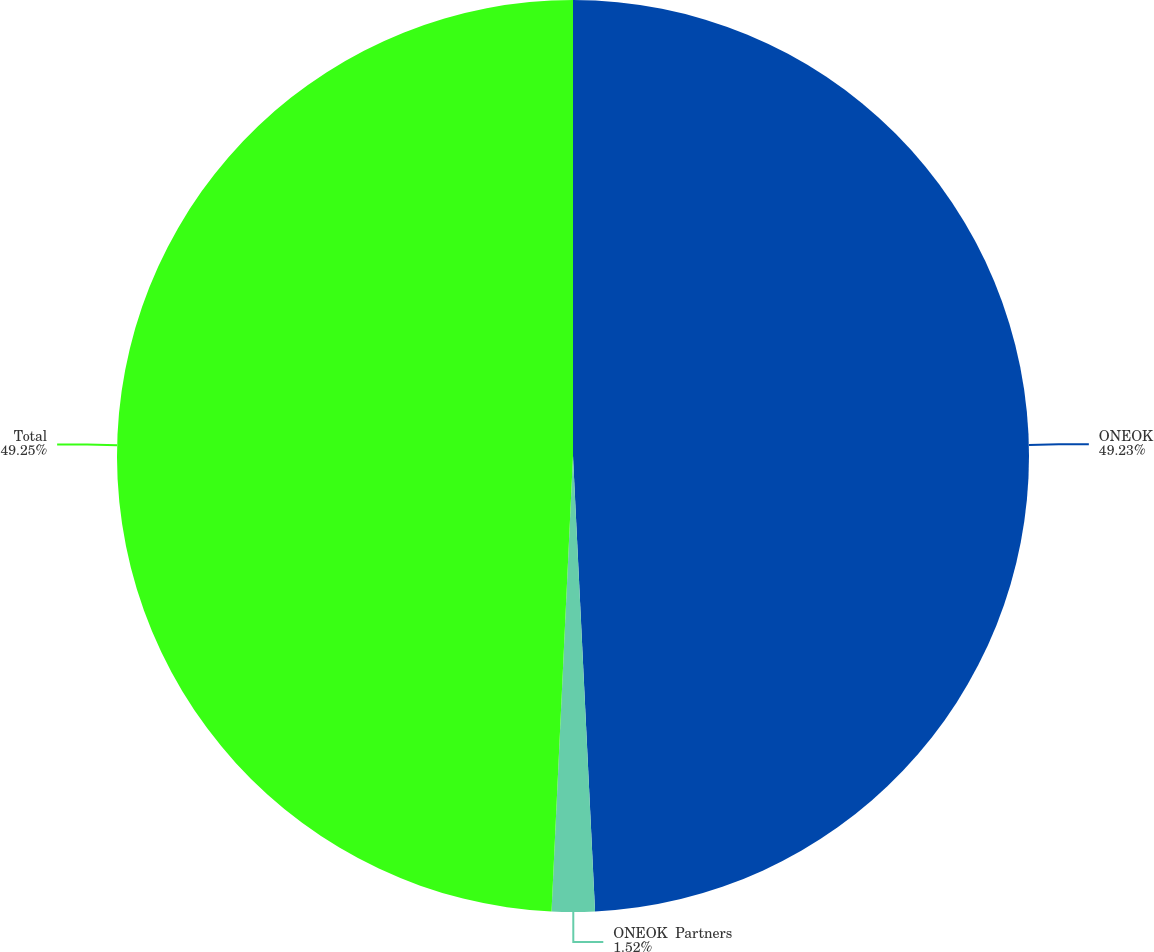Convert chart. <chart><loc_0><loc_0><loc_500><loc_500><pie_chart><fcel>ONEOK<fcel>ONEOK  Partners<fcel>Total<nl><fcel>49.23%<fcel>1.52%<fcel>49.25%<nl></chart> 